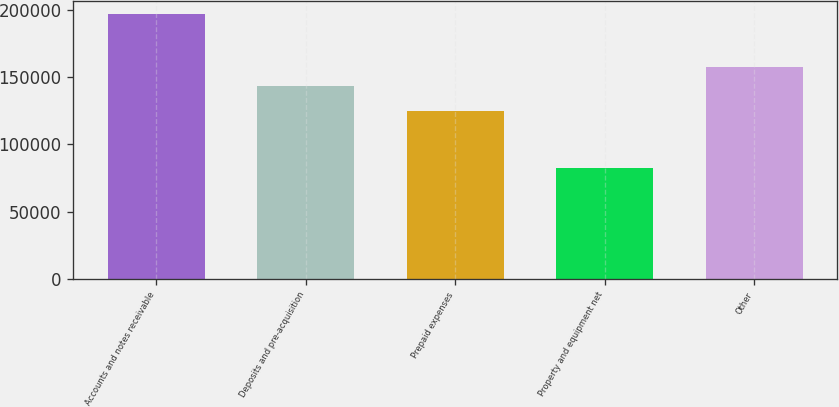Convert chart. <chart><loc_0><loc_0><loc_500><loc_500><bar_chart><fcel>Accounts and notes receivable<fcel>Deposits and pre-acquisition<fcel>Prepaid expenses<fcel>Property and equipment net<fcel>Other<nl><fcel>196622<fcel>143502<fcel>124790<fcel>82419<fcel>157707<nl></chart> 